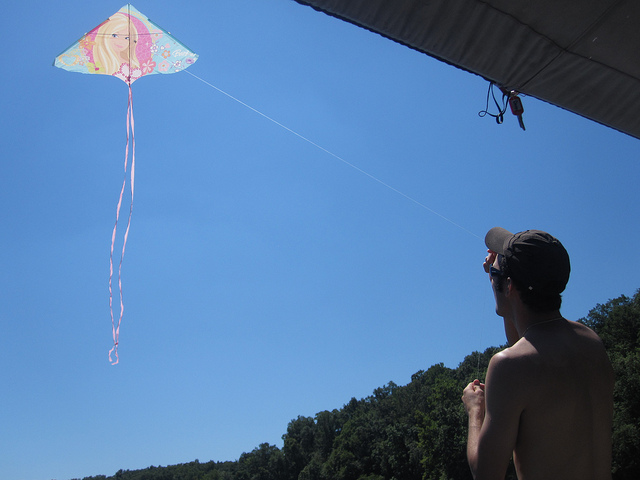Can you describe the person flying the kite? Certainly, there is a person in the foreground who seems to be enjoying the activity. He is wearing a sleeveless top and a cap, which suggests it's warm outside. His attention is focused skyward, managing the kite's movement with care. 